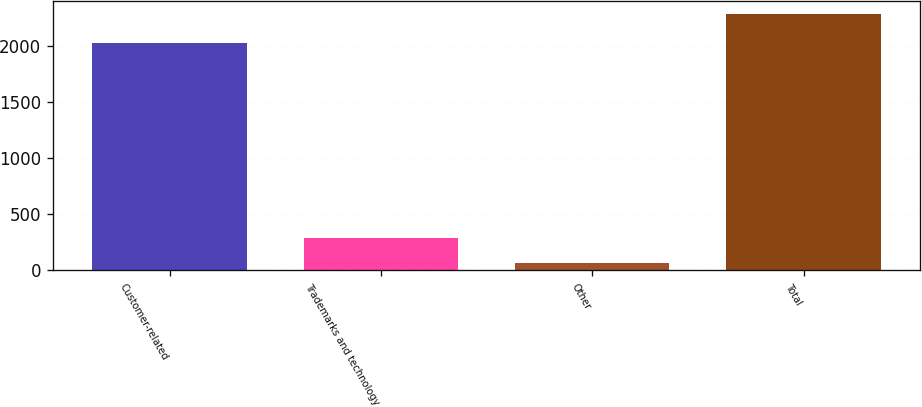Convert chart. <chart><loc_0><loc_0><loc_500><loc_500><bar_chart><fcel>Customer-related<fcel>Trademarks and technology<fcel>Other<fcel>Total<nl><fcel>2028<fcel>285.9<fcel>64<fcel>2283<nl></chart> 